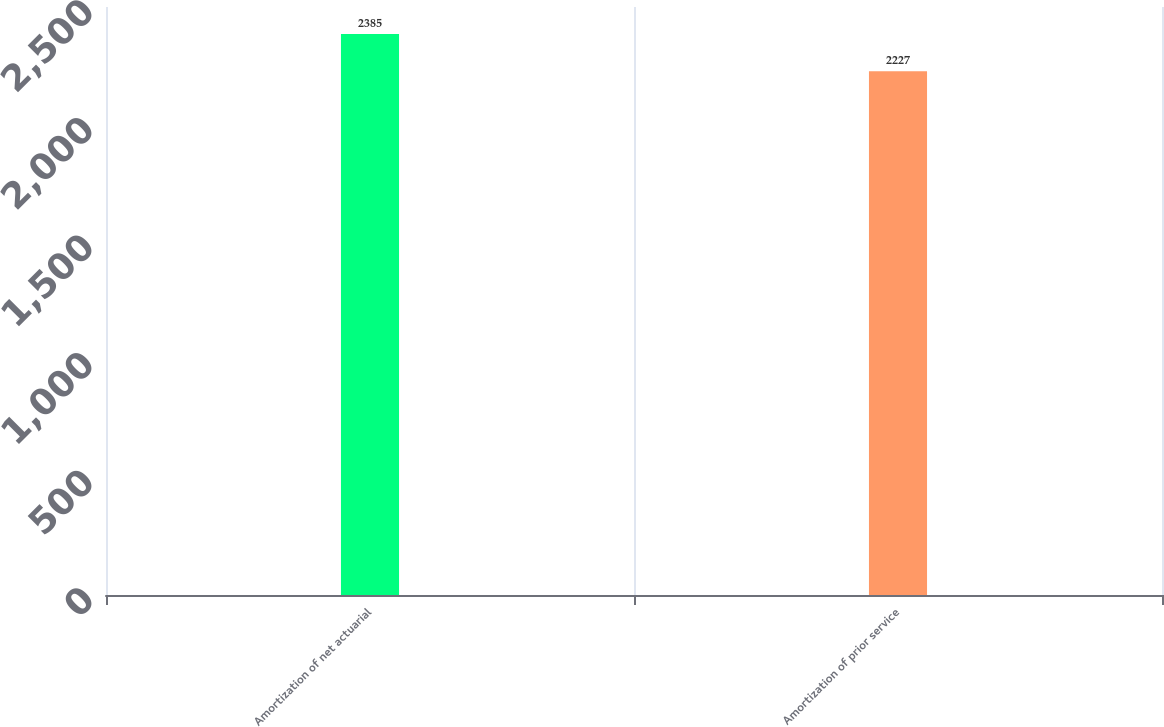Convert chart to OTSL. <chart><loc_0><loc_0><loc_500><loc_500><bar_chart><fcel>Amortization of net actuarial<fcel>Amortization of prior service<nl><fcel>2385<fcel>2227<nl></chart> 